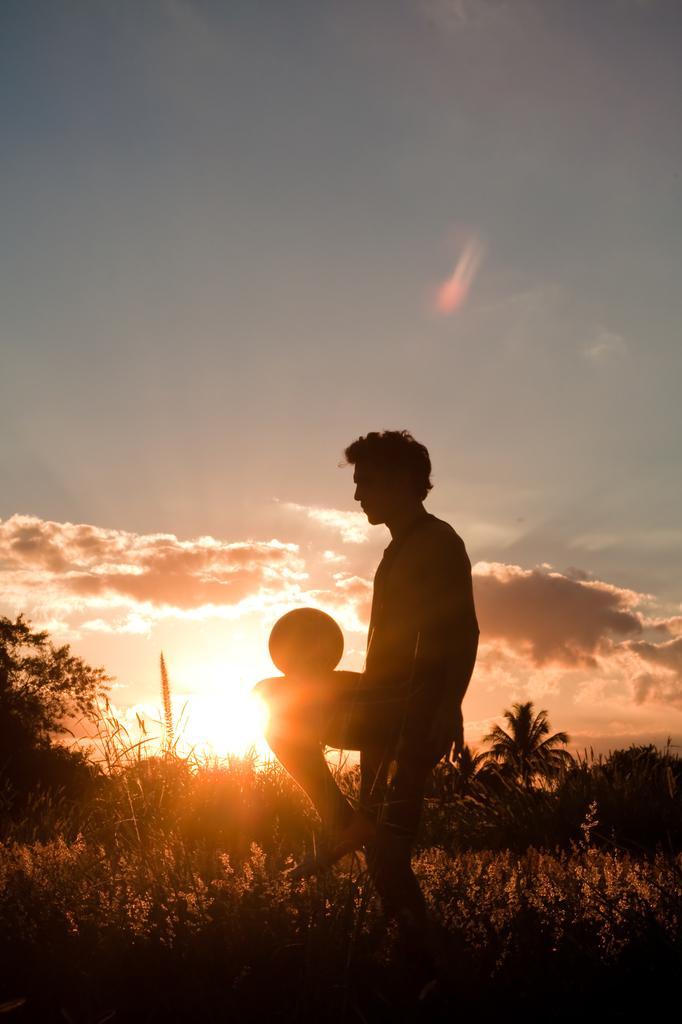How would you summarize this image in a sentence or two? In this image I can see a person wearing dress and shoe is standing on the ground and I can see a ball over here. In the background I can see few plants, few trees, the sky and the sun. 